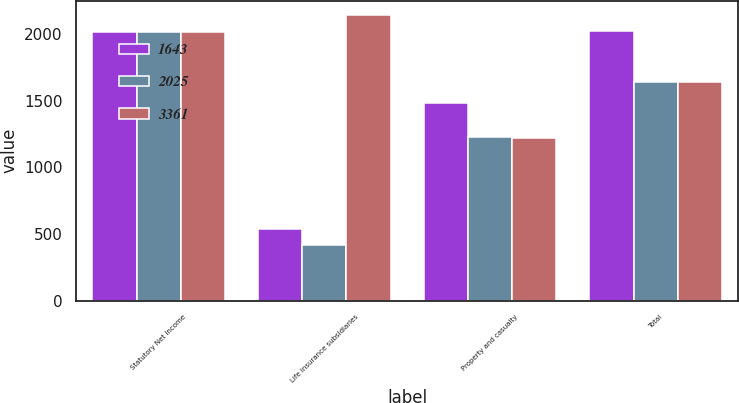Convert chart. <chart><loc_0><loc_0><loc_500><loc_500><stacked_bar_chart><ecel><fcel>Statutory Net Income<fcel>Life insurance subsidiaries<fcel>Property and casualty<fcel>Total<nl><fcel>1643<fcel>2015<fcel>539<fcel>1486<fcel>2025<nl><fcel>2025<fcel>2014<fcel>415<fcel>1228<fcel>1643<nl><fcel>3361<fcel>2013<fcel>2144<fcel>1217<fcel>1643<nl></chart> 